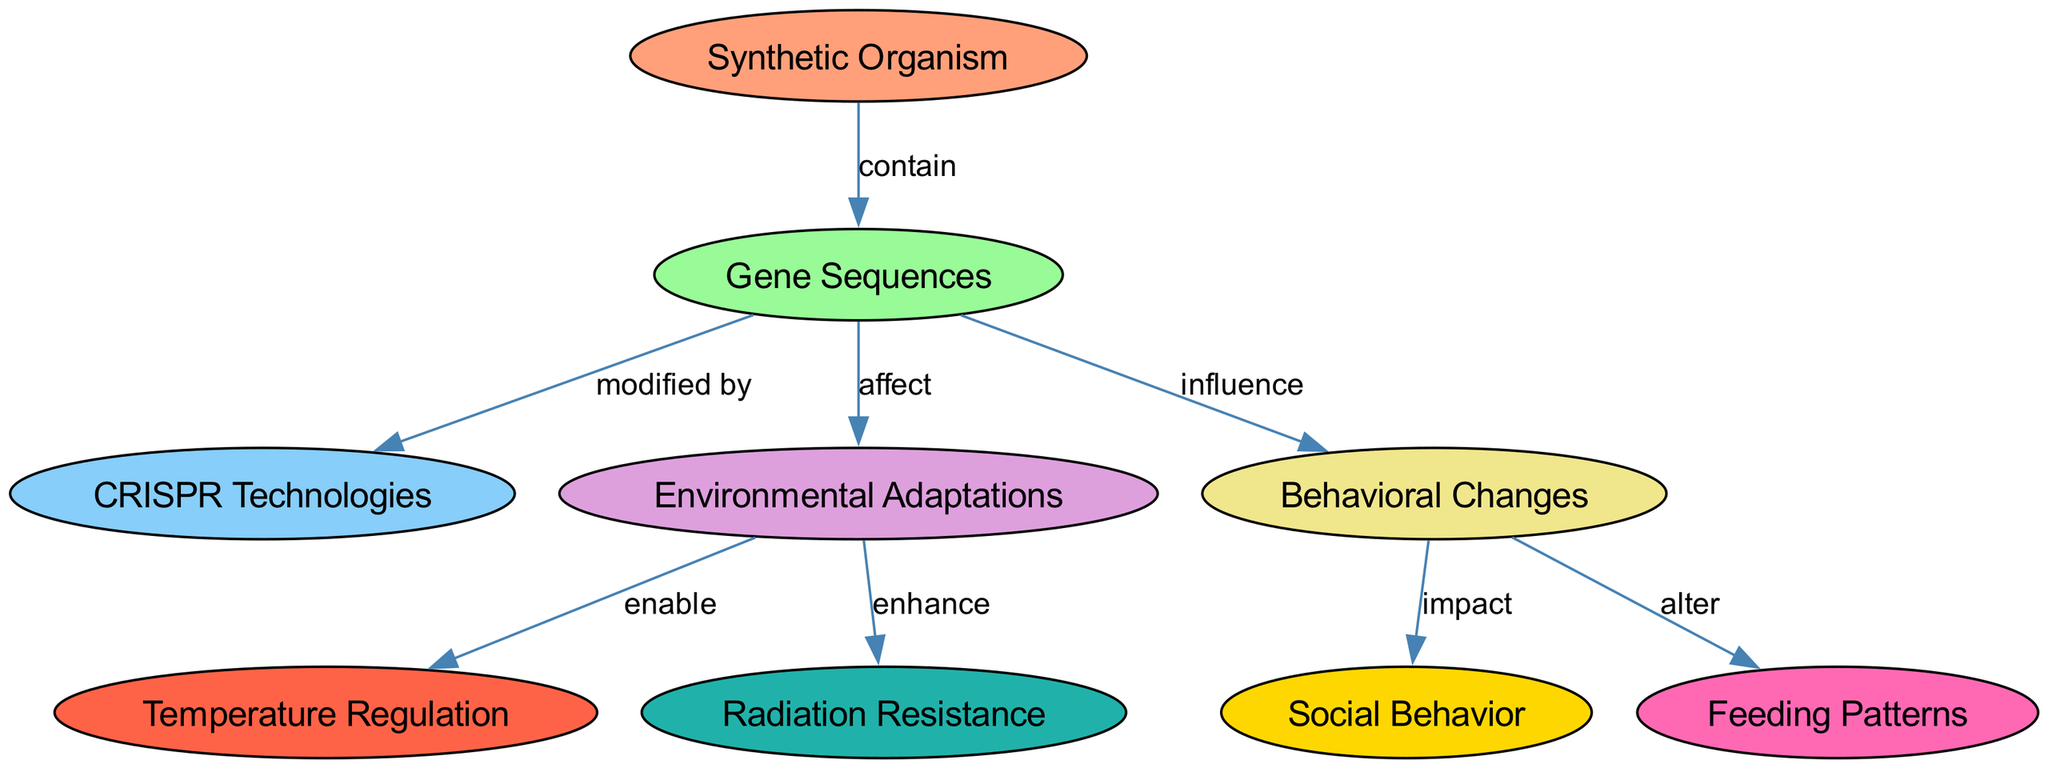What is the central node in the diagram? The central node in the diagram represents the primary concept around which the other nodes are organized; in this case, it is "Synthetic Organism."
Answer: Synthetic Organism How many nodes are present in the diagram? By counting all the unique nodes listed in the diagram, we find there are a total of nine distinct nodes.
Answer: 9 Which node is directly influenced by "Gene Sequences"? The diagram shows that "Behavioral Changes" is directly influenced by "Gene Sequences." This relationship is indicated by the edge connecting these two nodes.
Answer: Behavioral Changes What effect do "Environmental Adaptations" have on "Temperature Regulation"? The edge from "Environmental Adaptations" to "Temperature Regulation" shows that these adaptations enable temperature regulation in synthetic organisms.
Answer: enable What is the relationship between "Behavioral Changes" and "Social Behavior"? The diagram indicates that "Behavioral Changes" impact "Social Behavior." The edge between these two nodes illustrates this connection.
Answer: impact Do "Gene Sequences" affect "Radiation Resistance"? "Gene Sequences" do not directly affect "Radiation Resistance." Instead, they influence "Environmental Adaptations," which then enhance "Radiation Resistance." This requires following the flow of influence through multiple nodes.
Answer: No Which node directly follows "CRISPR Technologies"? There is no direct connection following "CRISPR Technologies" in the diagram. It serves as a modifier for "Gene Sequences." Thus, the next relevant node after could be considered "Environmental Adaptations," as they are affected by modifications made through CRISPR Technologies.
Answer: Environmental Adaptations What are the two outcomes resulting from "Environmental Adaptations"? "Environmental Adaptations" lead to two outcomes: enabling "Temperature Regulation" and enhancing "Radiation Resistance." Both outcomes are directly connected by edges from the "Environmental Adaptations" node.
Answer: Temperature Regulation, Radiation Resistance Which node describes changes in feeding behavior? The node that describes changes in feeding behavior is "Feeding Patterns." This node shows the effect that "Behavioral Changes" can have on how synthetic organisms feed.
Answer: Feeding Patterns 